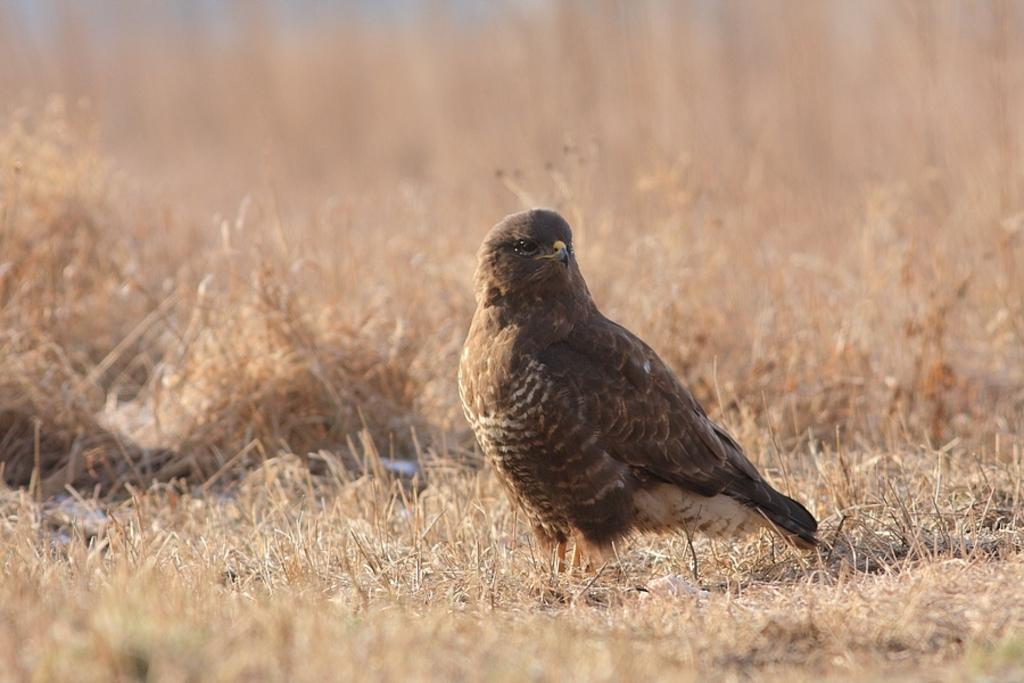What type of animal is present in the image? There is a bird in the image. What is the bird standing on? The bird is on dried grass. grass. What type of vacation did the bird take last year? There is no information about the bird's vacation or the year in the image, so it cannot be determined from the image. 